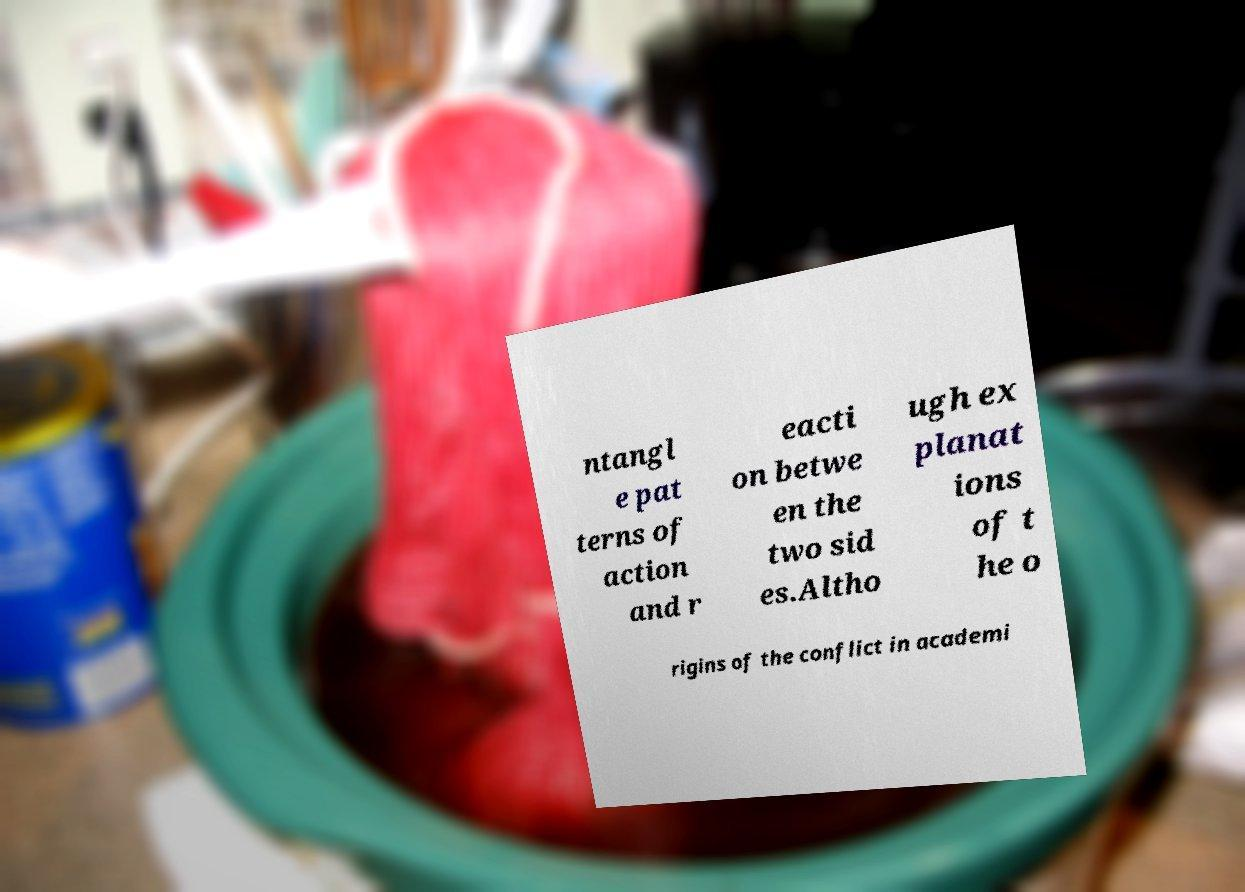Could you extract and type out the text from this image? ntangl e pat terns of action and r eacti on betwe en the two sid es.Altho ugh ex planat ions of t he o rigins of the conflict in academi 